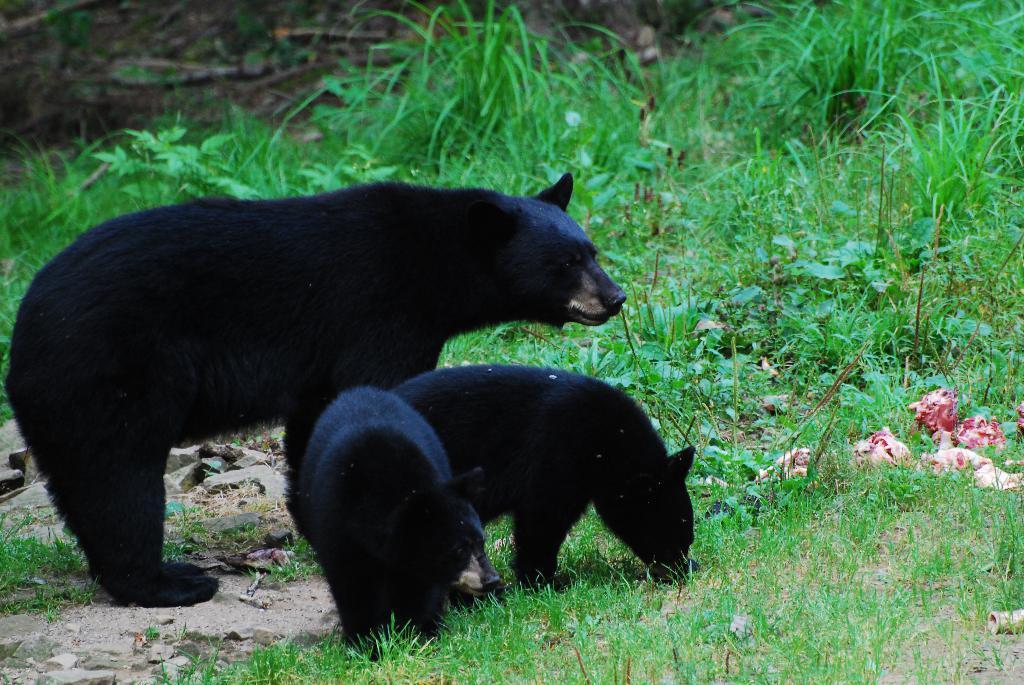Describe this image in one or two sentences. In this image we can some animals, there are plants, grass and some other objects on the ground. 